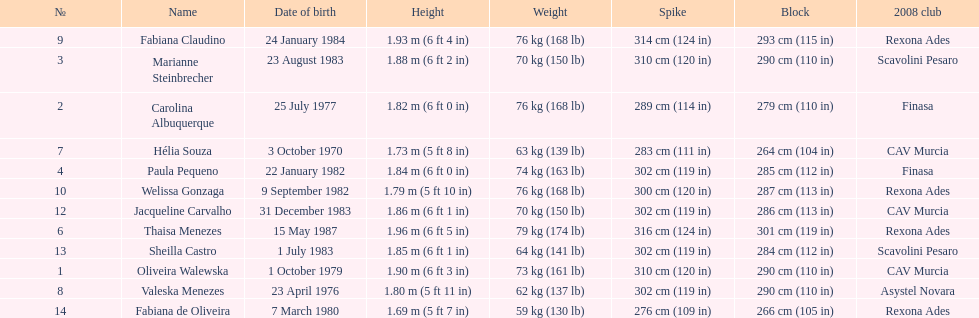Out of fabiana de oliveira, helia souza, and sheilla castro, who has the greatest weight? Sheilla Castro. 